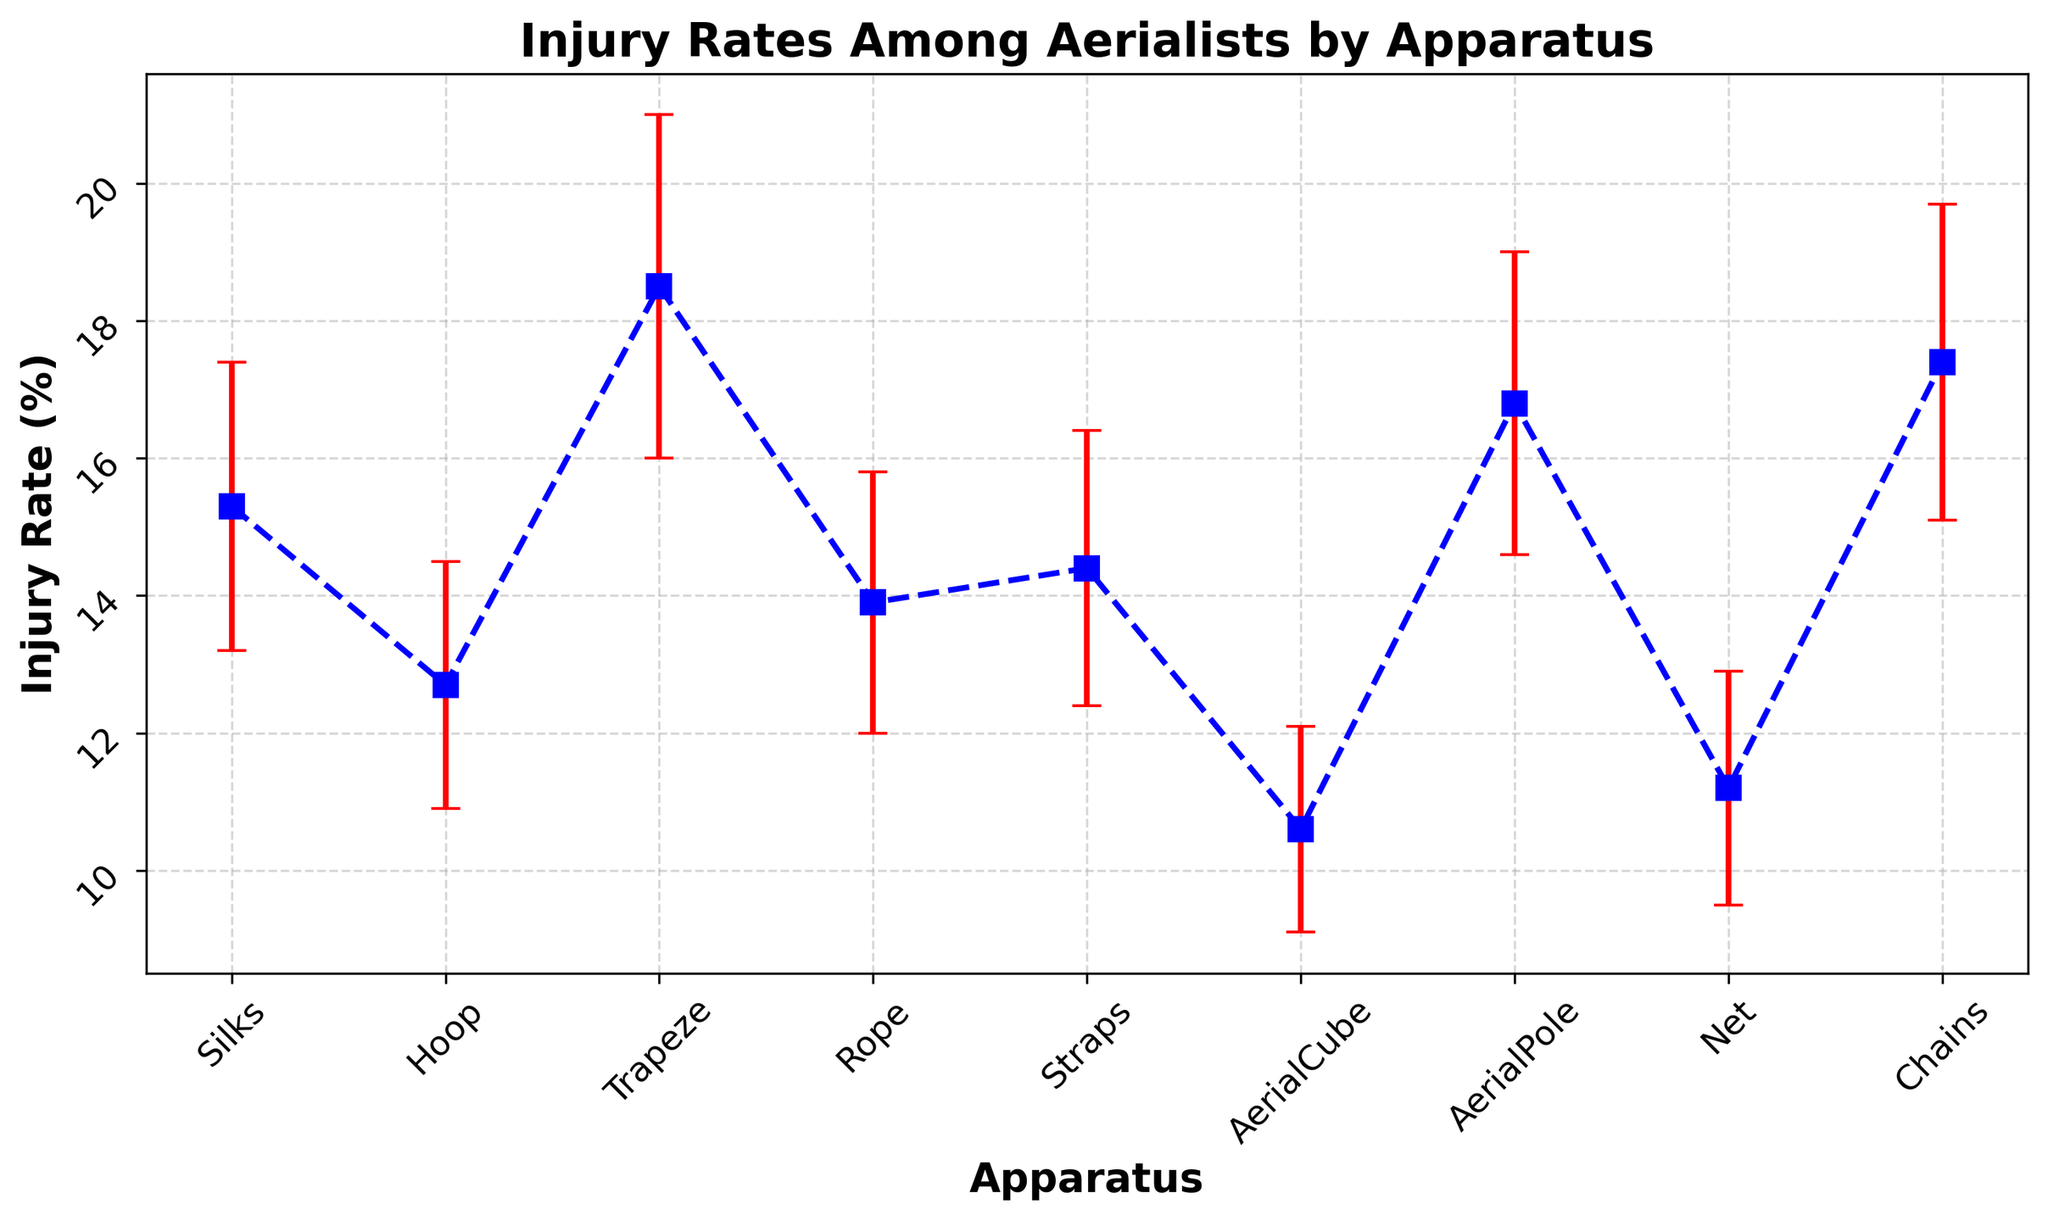Which apparatus has the highest injury rate? Examine the figure and look for the data point that reaches the highest position on the y-axis. The apparatus with the highest injury rate is Trapeze.
Answer: Trapeze Which apparatus has the lowest injury rate? Examine the figure and look for the data point that reaches the lowest position on the y-axis. The apparatus with the lowest injury rate is AerialCube.
Answer: AerialCube What is the difference in injury rates between the apparatus with the highest and the lowest injury rates? Subtract the injury rate of the apparatus with the lowest injury rate (AerialCube) from the one with the highest injury rate (Trapeze). The calculation is 18.5% - 10.6%.
Answer: 7.9% Which apparatus has a higher injury rate: Silks or Rope? Compare the height of the data points for Silks and Rope on the y-axis. Silks has an injury rate of 15.3%, and Rope has 13.9%.
Answer: Silks How many apparatuses have injury rates higher than 15%? Count the number of data points on the figure that are positioned above the 15% mark on the y-axis. The apparatuses are Silks, Trapeze, AerialPole, and Chains.
Answer: 4 Which has a greater variability in injury rate: Hoop or AerialCube? Compare the lengths of the error bars for Hoop and AerialCube. Hoop has a standard error of 1.8%, and AerialCube has 1.5%. Therefore, Hoop has greater variability.
Answer: Hoop Is there any apparatus with an injury rate that is exactly the same as another? Check the figure to see if any data points lie at the same height on the y-axis. No data points are exactly at the same height.
Answer: No Which two apparatuses have the closest injury rates? Compare the proximity of adjacent data points to identify the two closest. Silks and Straps are close, but Silks and Rope are closer with injury rates of 15.3% and 14.4%, respectively.
Answer: Silks and Straps If you average the injury rates of Net and Chains, what is the result? Add the injury rates of Net and Chains and divide by 2. The calculation is (11.2% + 17.4%) / 2.
Answer: 14.3% What is the range of injury rates among all apparatuses? Subtract the lowest injury rate (AerialCube, 10.6%) from the highest injury rate (Trapeze, 18.5%) to find the range. The calculation is 18.5% - 10.6%.
Answer: 7.9% 